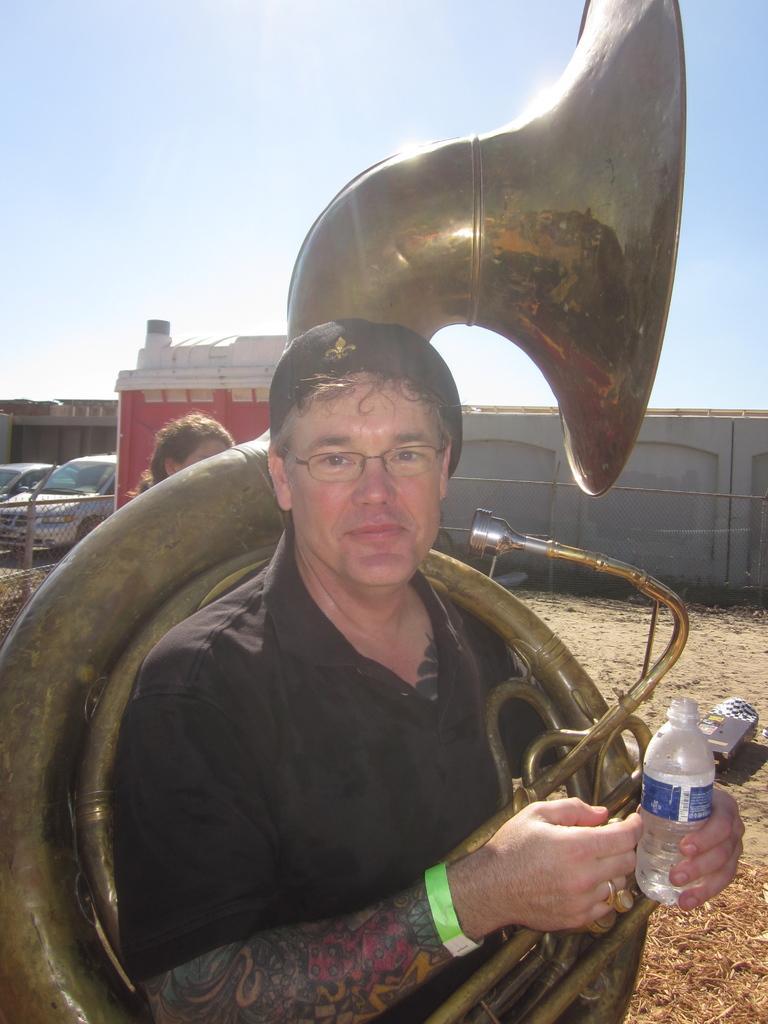Can you describe this image briefly? In this Picture we can see a man wearing black t- shirt with black cap on the head standing and smiling giving the pose for the photo. Holding a water bottle in the right hand and a big golden saxophone in this arm. Behind we can see the grey color wall with iron fencing and some parked car and a blue clear sky. 